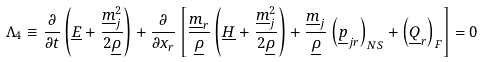Convert formula to latex. <formula><loc_0><loc_0><loc_500><loc_500>\Lambda _ { 4 } \equiv \frac { \partial } { \partial t } \left ( \underline { E } + \frac { \underline { m } ^ { 2 } _ { j } } { 2 \underline { \rho } } \right ) + \frac { \partial } { \partial x _ { r } } \left [ \frac { \underline { m } _ { r } } { \underline { \rho } } \left ( \underline { H } + \frac { \underline { m } ^ { 2 } _ { j } } { 2 \underline { \rho } } \right ) + \frac { \underline { m } _ { j } } { \underline { \rho } } \left ( \underline { p } _ { j r } \right ) _ { N S } + \left ( \underline { Q } _ { r } \right ) _ { F } \right ] = 0</formula> 